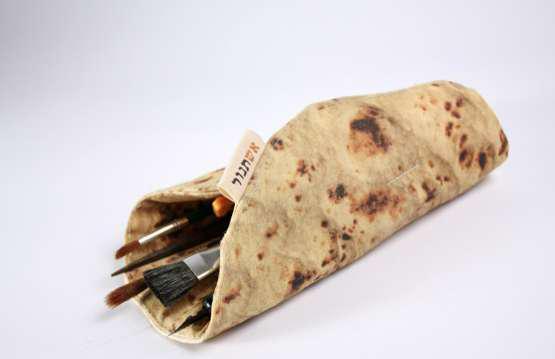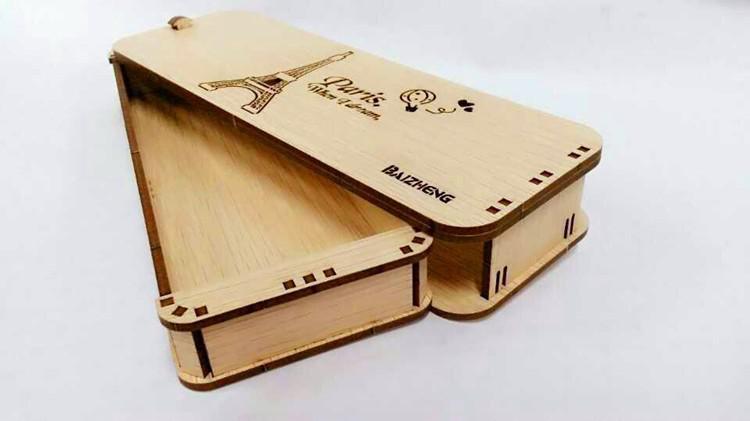The first image is the image on the left, the second image is the image on the right. Given the left and right images, does the statement "There is at least one open wooden pencil case." hold true? Answer yes or no. Yes. 